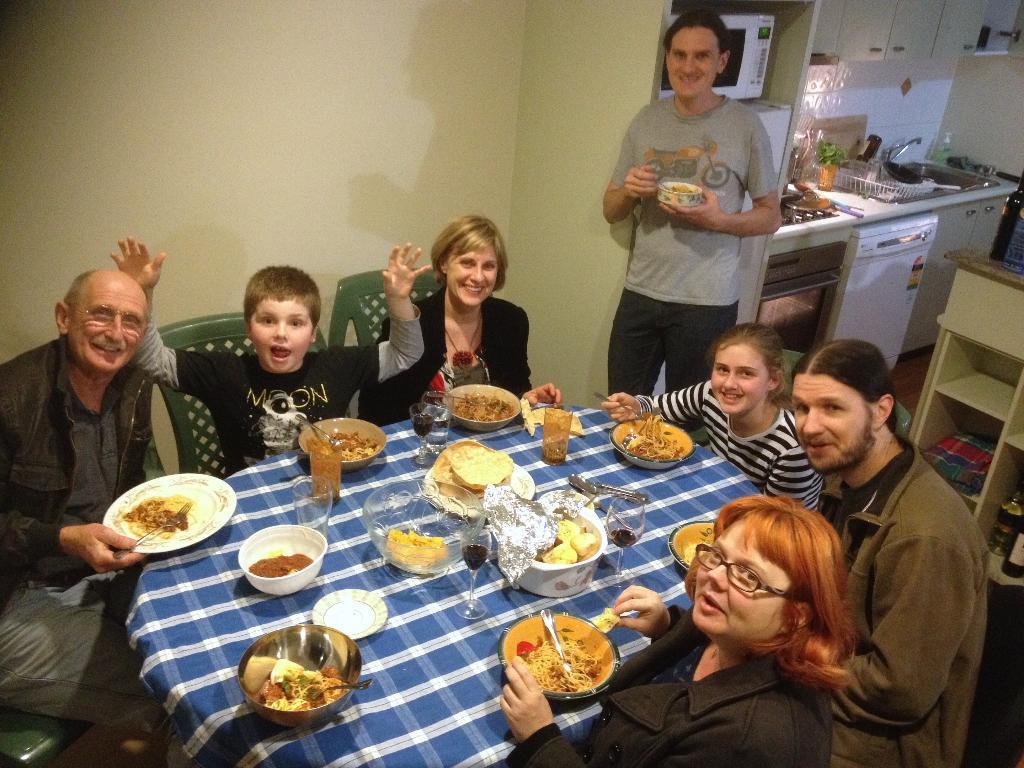Could you give a brief overview of what you see in this image? There are some people sitting in the chairs around the table on which some food items were placed. In the plates and bowls there are some glasses and spoons. Around the table there are men, women and children were there. One of the guy is standing here. In the background there is a kitchen. 